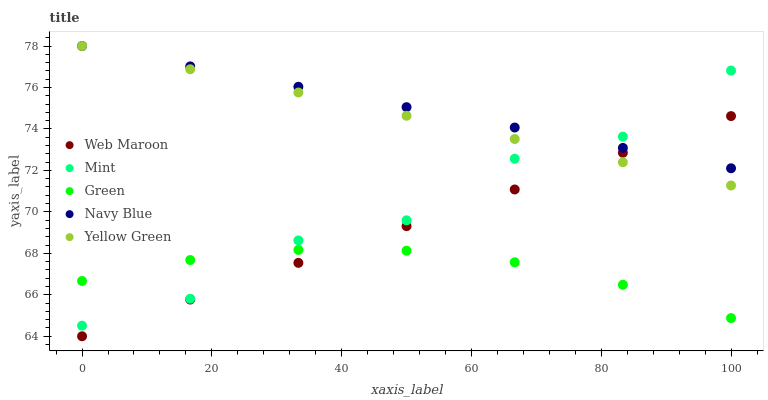Does Green have the minimum area under the curve?
Answer yes or no. Yes. Does Navy Blue have the maximum area under the curve?
Answer yes or no. Yes. Does Web Maroon have the minimum area under the curve?
Answer yes or no. No. Does Web Maroon have the maximum area under the curve?
Answer yes or no. No. Is Web Maroon the smoothest?
Answer yes or no. Yes. Is Mint the roughest?
Answer yes or no. Yes. Is Green the smoothest?
Answer yes or no. No. Is Green the roughest?
Answer yes or no. No. Does Web Maroon have the lowest value?
Answer yes or no. Yes. Does Green have the lowest value?
Answer yes or no. No. Does Navy Blue have the highest value?
Answer yes or no. Yes. Does Web Maroon have the highest value?
Answer yes or no. No. Is Web Maroon less than Mint?
Answer yes or no. Yes. Is Navy Blue greater than Green?
Answer yes or no. Yes. Does Green intersect Web Maroon?
Answer yes or no. Yes. Is Green less than Web Maroon?
Answer yes or no. No. Is Green greater than Web Maroon?
Answer yes or no. No. Does Web Maroon intersect Mint?
Answer yes or no. No. 